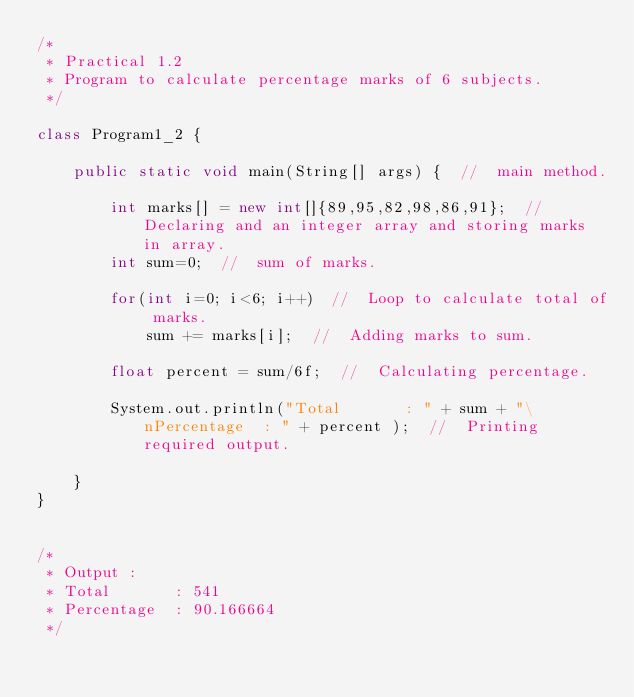<code> <loc_0><loc_0><loc_500><loc_500><_Java_>/*
 * Practical 1.2
 * Program to calculate percentage marks of 6 subjects.
 */

class Program1_2 {

	public static void main(String[] args) {  //  main method.
		
		int marks[] = new int[]{89,95,82,98,86,91};  //  Declaring and an integer array and storing marks in array.
		int sum=0;  //  sum of marks.
		
		for(int i=0; i<6; i++)  //  Loop to calculate total of marks.
			sum += marks[i];  //  Adding marks to sum.
		
		float percent = sum/6f;  //  Calculating percentage.
		
		System.out.println("Total       : " + sum + "\nPercentage  : " + percent );  //  Printing required output.
		
	}
}


/*
 * Output : 
 * Total       : 541
 * Percentage  : 90.166664
 */
</code> 